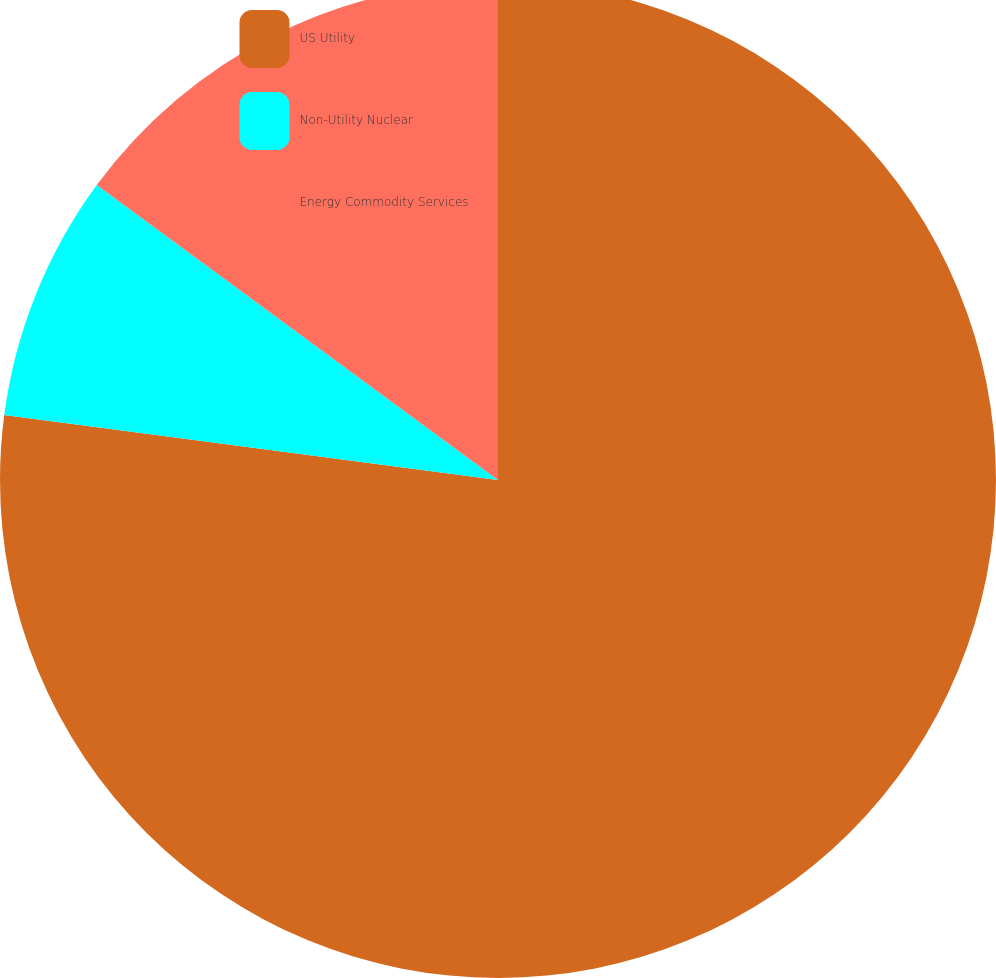<chart> <loc_0><loc_0><loc_500><loc_500><pie_chart><fcel>US Utility<fcel>Non-Utility Nuclear<fcel>Energy Commodity Services<nl><fcel>77.08%<fcel>8.01%<fcel>14.91%<nl></chart> 